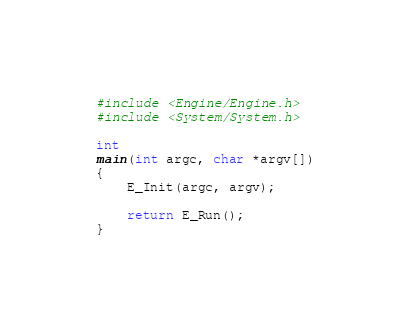<code> <loc_0><loc_0><loc_500><loc_500><_C_>#include <Engine/Engine.h>
#include <System/System.h>

int
main(int argc, char *argv[])
{
	E_Init(argc, argv);

	return E_Run();
}
</code> 